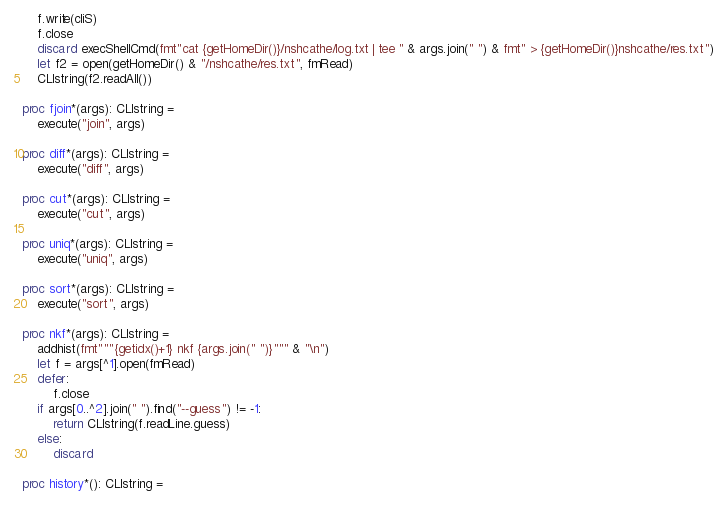<code> <loc_0><loc_0><loc_500><loc_500><_Nim_>    f.write(cliS)
    f.close
    discard execShellCmd(fmt"cat {getHomeDir()}/nshcathe/log.txt | tee " & args.join(" ") & fmt" > {getHomeDir()}nshcathe/res.txt")
    let f2 = open(getHomeDir() & "/nshcathe/res.txt", fmRead)
    CLIstring(f2.readAll())

proc fjoin*(args): CLIstring =
    execute("join", args)

proc diff*(args): CLIstring =
    execute("diff", args)

proc cut*(args): CLIstring =
    execute("cut", args)

proc uniq*(args): CLIstring =
    execute("uniq", args)

proc sort*(args): CLIstring =
    execute("sort", args)

proc nkf*(args): CLIstring =
    addhist(fmt"""{getidx()+1} nkf {args.join(" ")}""" & "\n")
    let f = args[^1].open(fmRead)
    defer:
        f.close
    if args[0..^2].join(" ").find("--guess") != -1:
        return CLIstring(f.readLine.guess)
    else:
        discard

proc history*(): CLIstring =</code> 